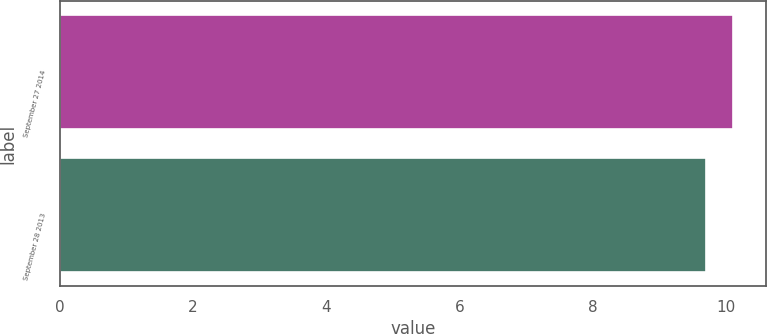<chart> <loc_0><loc_0><loc_500><loc_500><bar_chart><fcel>September 27 2014<fcel>September 28 2013<nl><fcel>10.1<fcel>9.7<nl></chart> 